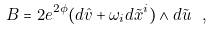Convert formula to latex. <formula><loc_0><loc_0><loc_500><loc_500>B = 2 e ^ { 2 \phi } ( d \hat { v } + \omega _ { i } d \tilde { x } ^ { i } ) \wedge d \tilde { u } \ ,</formula> 